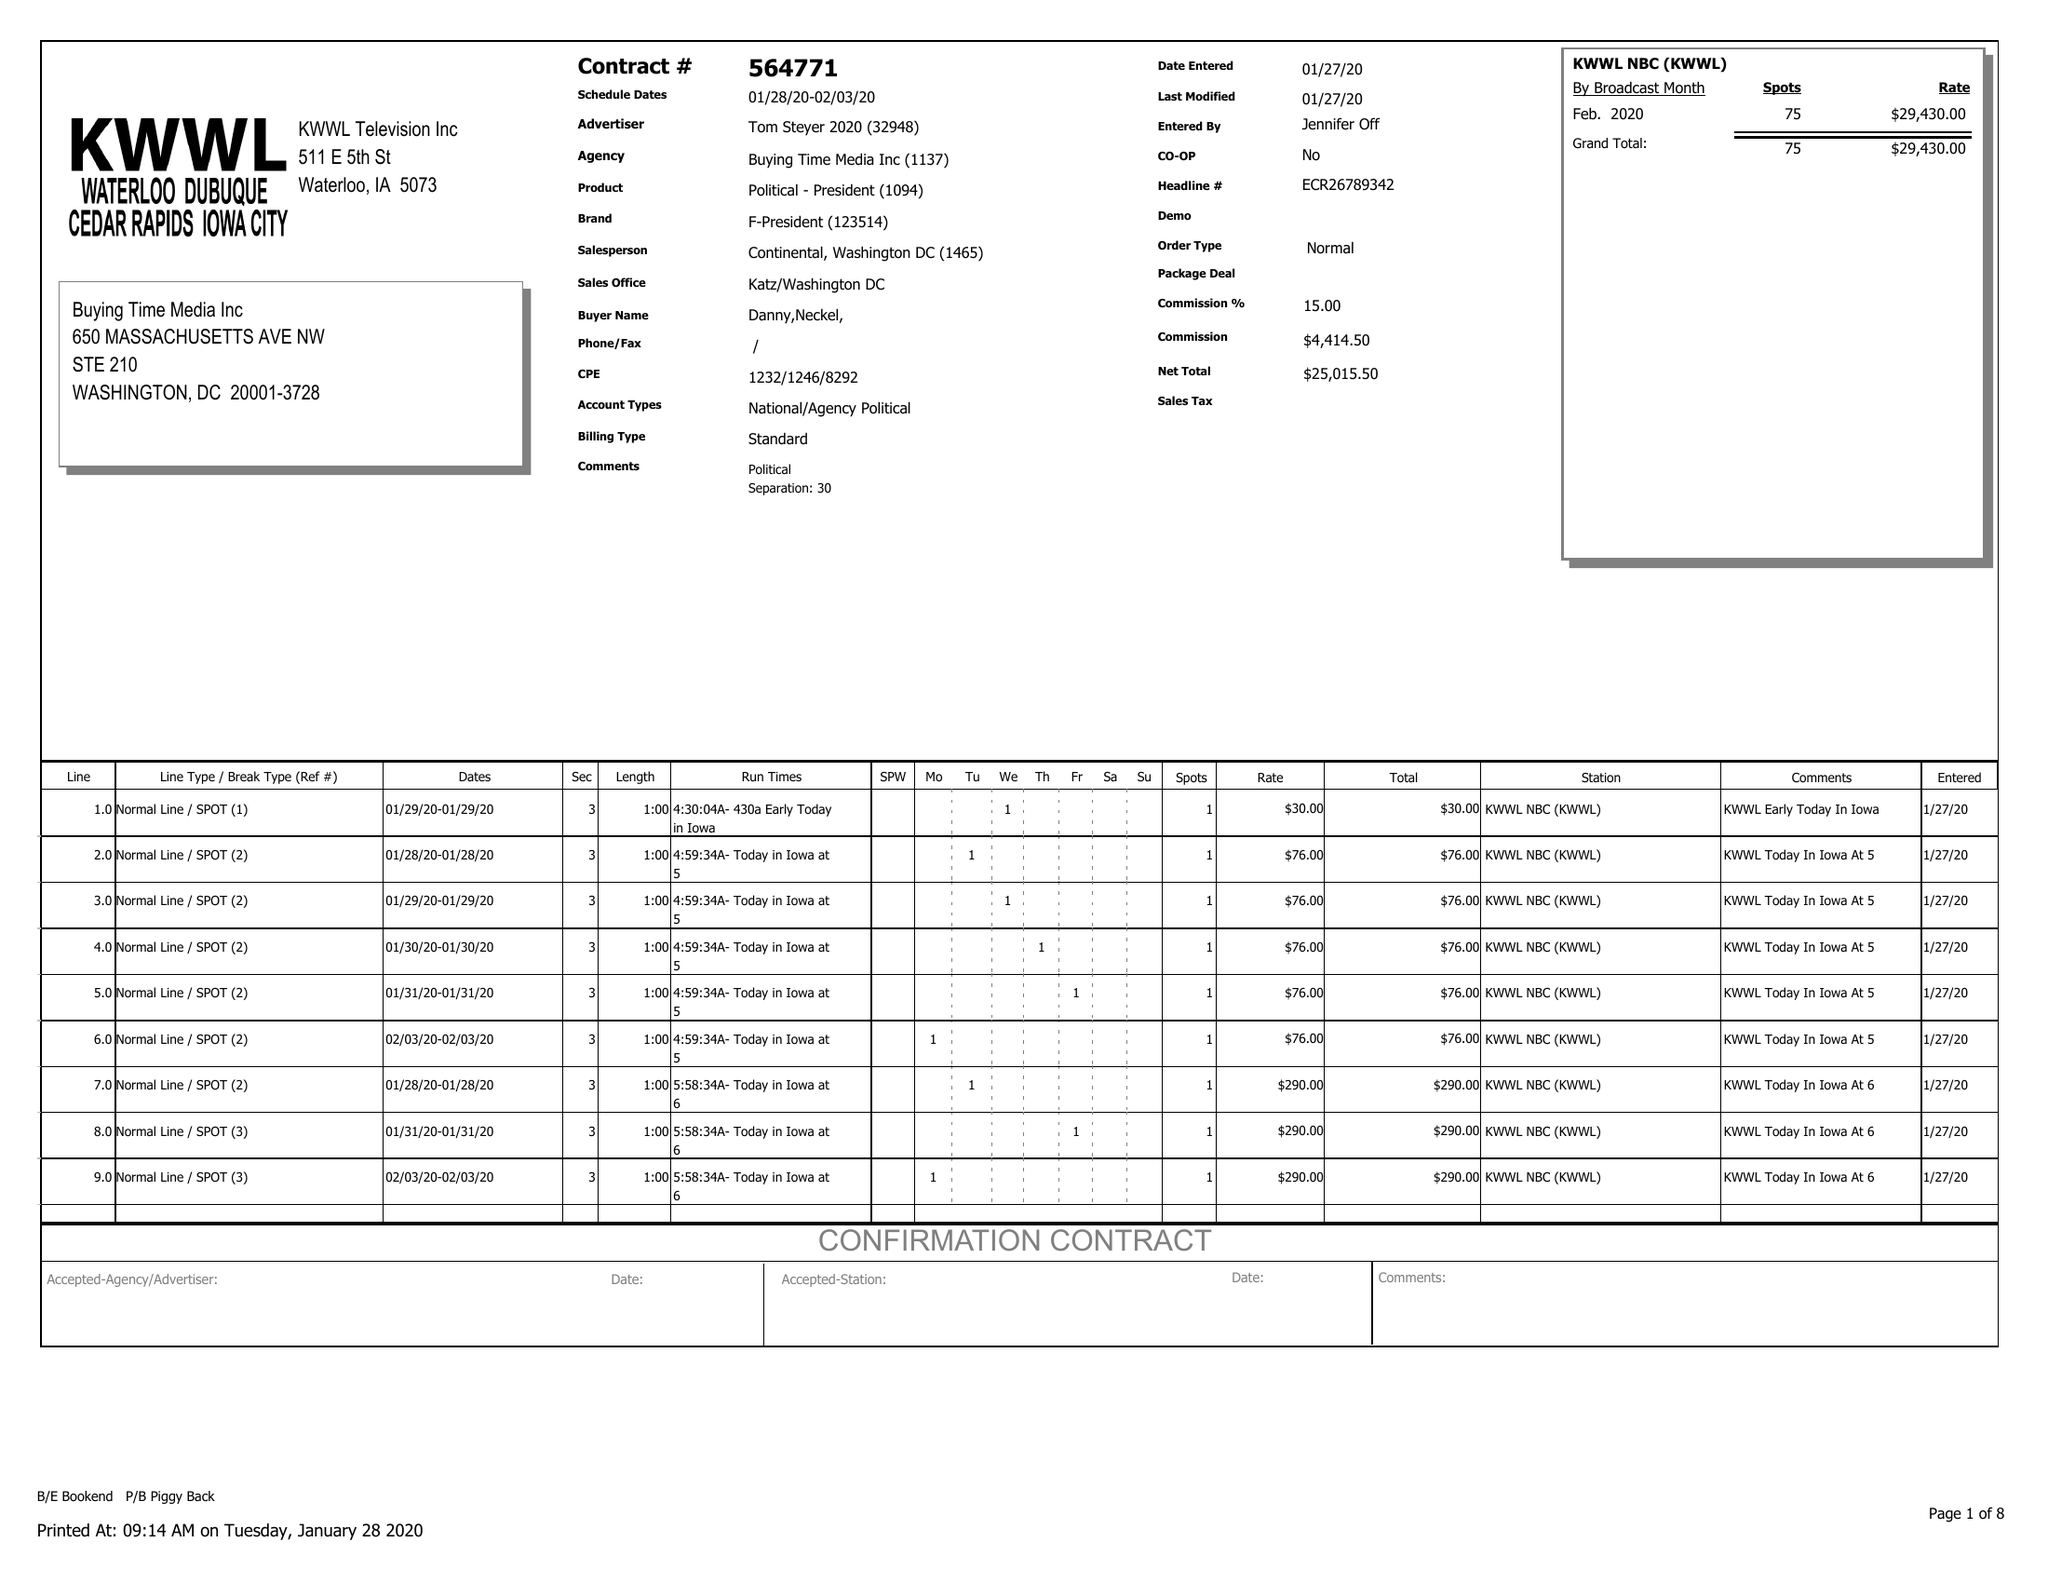What is the value for the contract_num?
Answer the question using a single word or phrase. 564771 